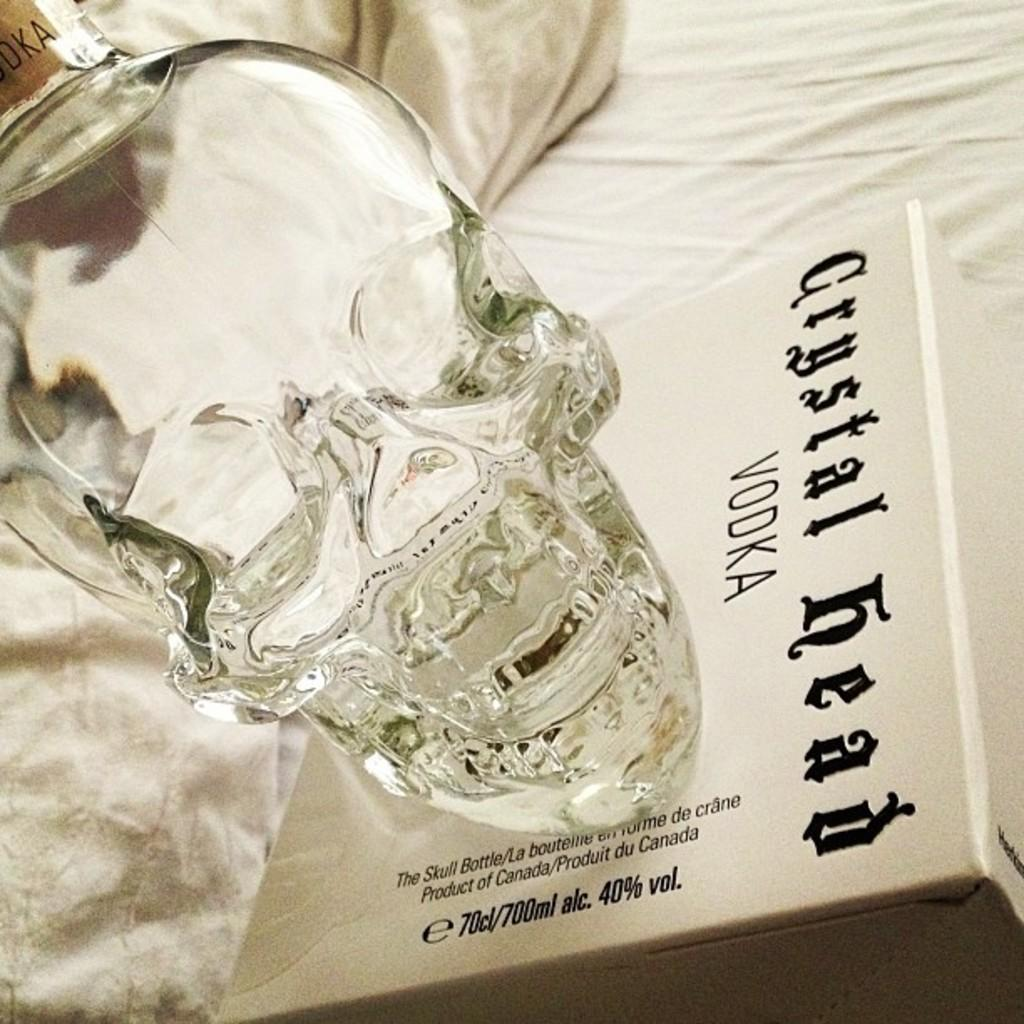<image>
Present a compact description of the photo's key features. A skull bottle of Crystal Head vodka sitting on a box. 